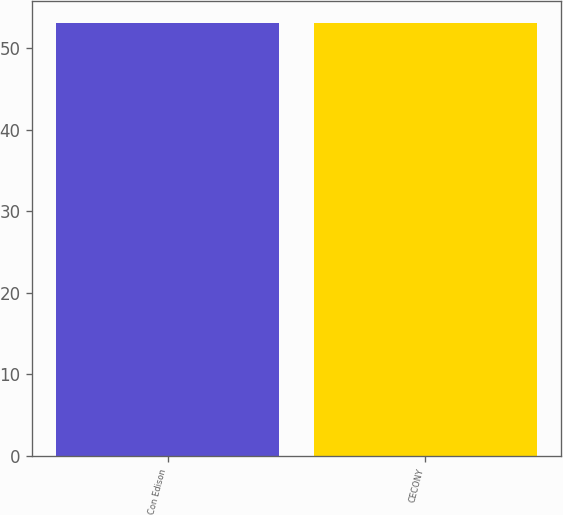Convert chart. <chart><loc_0><loc_0><loc_500><loc_500><bar_chart><fcel>Con Edison<fcel>CECONY<nl><fcel>53<fcel>53.1<nl></chart> 